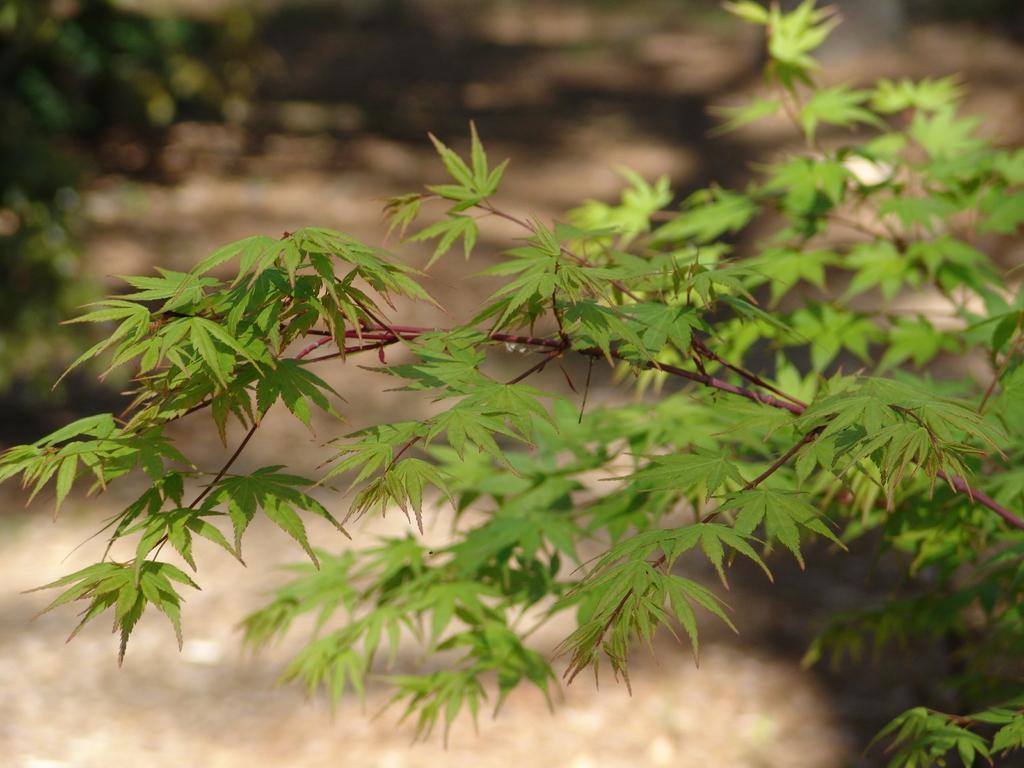In one or two sentences, can you explain what this image depicts? In this image in front there are trees and the background of the image is blur. 